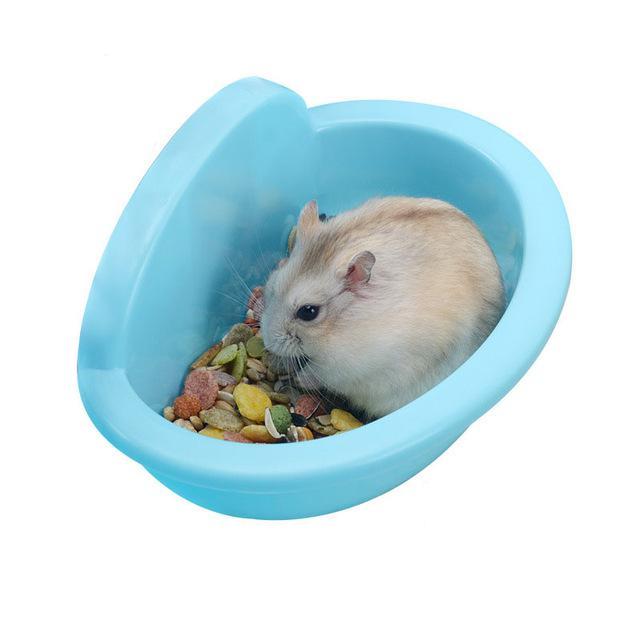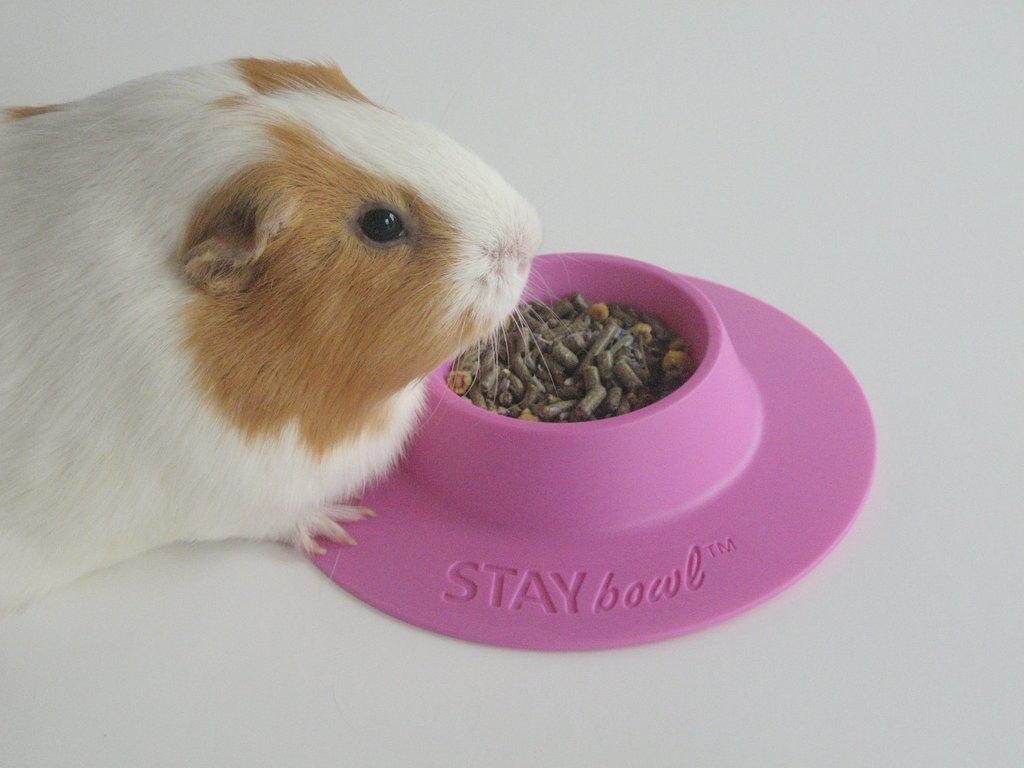The first image is the image on the left, the second image is the image on the right. Given the left and right images, does the statement "In the image on the left an animal is sitting in a bowl." hold true? Answer yes or no. Yes. The first image is the image on the left, the second image is the image on the right. Examine the images to the left and right. Is the description "The hamster in the left image is inside a bowl, and the hamster on the right is next to a bowl filled with pet food." accurate? Answer yes or no. Yes. 